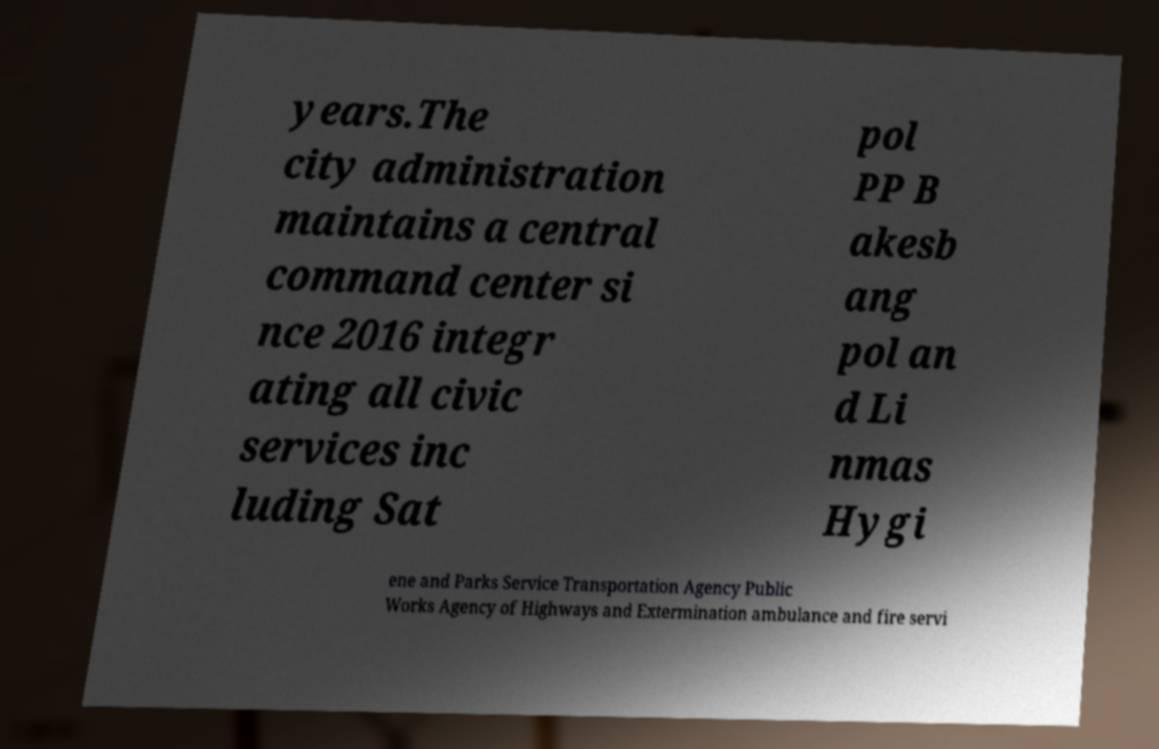I need the written content from this picture converted into text. Can you do that? years.The city administration maintains a central command center si nce 2016 integr ating all civic services inc luding Sat pol PP B akesb ang pol an d Li nmas Hygi ene and Parks Service Transportation Agency Public Works Agency of Highways and Extermination ambulance and fire servi 